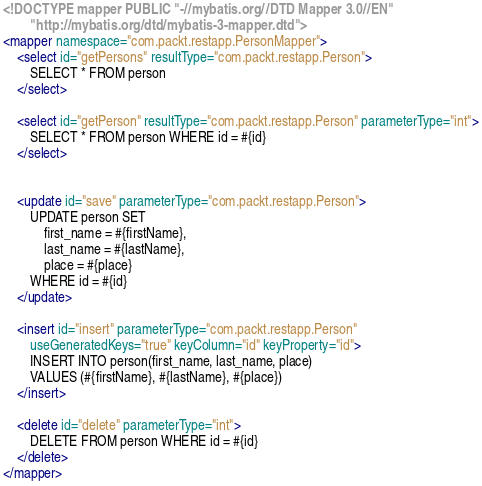<code> <loc_0><loc_0><loc_500><loc_500><_XML_><!DOCTYPE mapper PUBLIC "-//mybatis.org//DTD Mapper 3.0//EN"
        "http://mybatis.org/dtd/mybatis-3-mapper.dtd">
<mapper namespace="com.packt.restapp.PersonMapper">
    <select id="getPersons" resultType="com.packt.restapp.Person">
        SELECT * FROM person
    </select>

    <select id="getPerson" resultType="com.packt.restapp.Person" parameterType="int">
        SELECT * FROM person WHERE id = #{id}
    </select>


    <update id="save" parameterType="com.packt.restapp.Person">
        UPDATE person SET
            first_name = #{firstName},
            last_name = #{lastName},
            place = #{place}
        WHERE id = #{id}
    </update>

    <insert id="insert" parameterType="com.packt.restapp.Person"
        useGeneratedKeys="true" keyColumn="id" keyProperty="id">
        INSERT INTO person(first_name, last_name, place)
        VALUES (#{firstName}, #{lastName}, #{place})
    </insert>

    <delete id="delete" parameterType="int">
        DELETE FROM person WHERE id = #{id}
    </delete>
</mapper></code> 